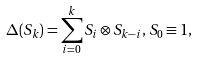Convert formula to latex. <formula><loc_0><loc_0><loc_500><loc_500>\Delta ( S _ { k } ) = \sum _ { i = 0 } ^ { k } S _ { i } \otimes S _ { k - i } , \, S _ { 0 } \equiv 1 ,</formula> 